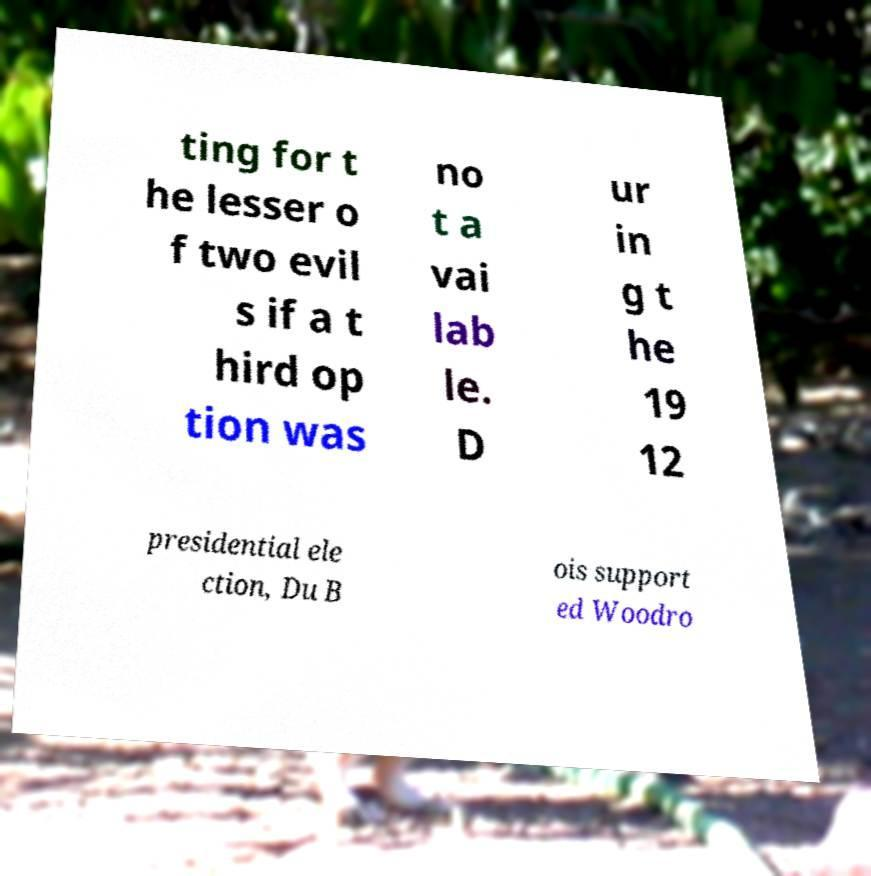Can you accurately transcribe the text from the provided image for me? ting for t he lesser o f two evil s if a t hird op tion was no t a vai lab le. D ur in g t he 19 12 presidential ele ction, Du B ois support ed Woodro 